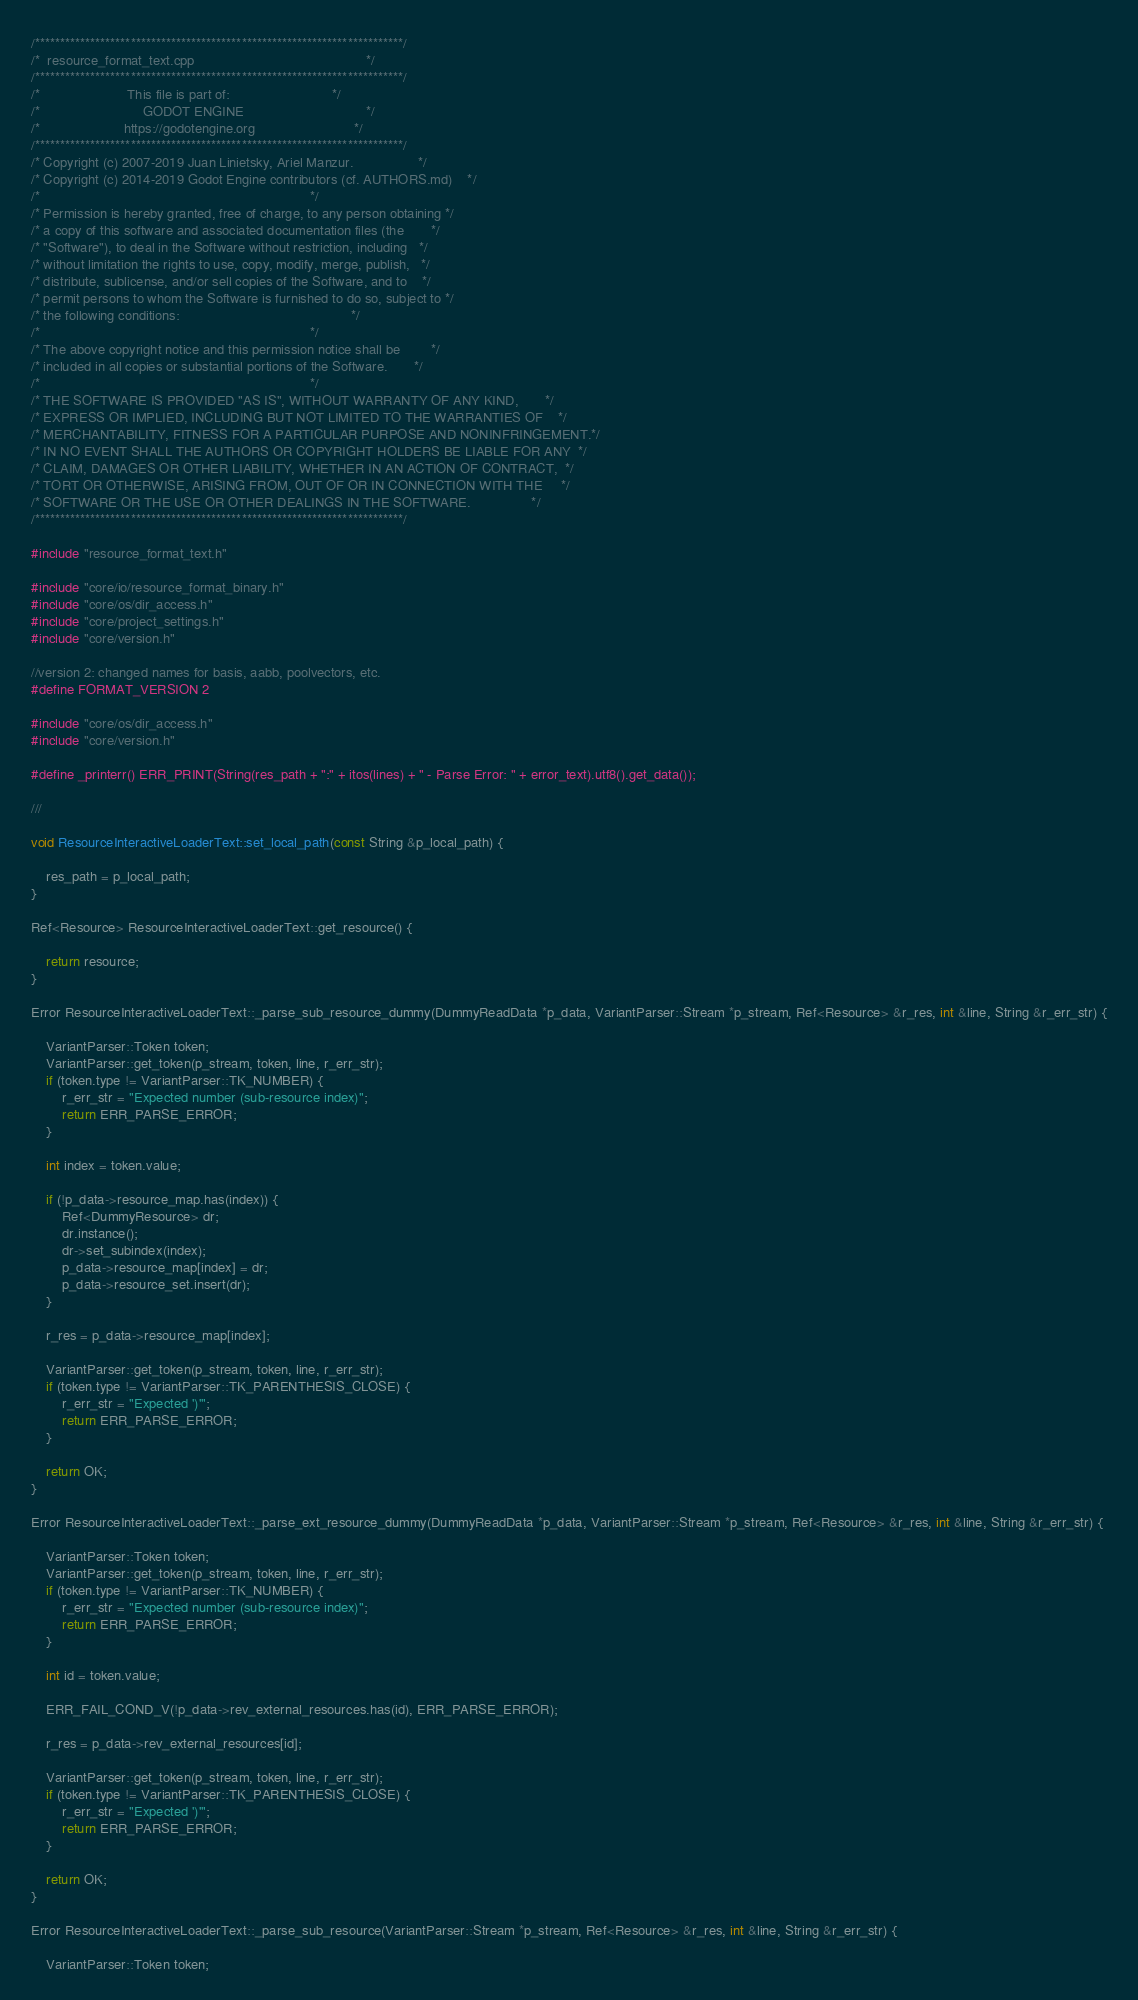Convert code to text. <code><loc_0><loc_0><loc_500><loc_500><_C++_>/*************************************************************************/
/*  resource_format_text.cpp                                             */
/*************************************************************************/
/*                       This file is part of:                           */
/*                           GODOT ENGINE                                */
/*                      https://godotengine.org                          */
/*************************************************************************/
/* Copyright (c) 2007-2019 Juan Linietsky, Ariel Manzur.                 */
/* Copyright (c) 2014-2019 Godot Engine contributors (cf. AUTHORS.md)    */
/*                                                                       */
/* Permission is hereby granted, free of charge, to any person obtaining */
/* a copy of this software and associated documentation files (the       */
/* "Software"), to deal in the Software without restriction, including   */
/* without limitation the rights to use, copy, modify, merge, publish,   */
/* distribute, sublicense, and/or sell copies of the Software, and to    */
/* permit persons to whom the Software is furnished to do so, subject to */
/* the following conditions:                                             */
/*                                                                       */
/* The above copyright notice and this permission notice shall be        */
/* included in all copies or substantial portions of the Software.       */
/*                                                                       */
/* THE SOFTWARE IS PROVIDED "AS IS", WITHOUT WARRANTY OF ANY KIND,       */
/* EXPRESS OR IMPLIED, INCLUDING BUT NOT LIMITED TO THE WARRANTIES OF    */
/* MERCHANTABILITY, FITNESS FOR A PARTICULAR PURPOSE AND NONINFRINGEMENT.*/
/* IN NO EVENT SHALL THE AUTHORS OR COPYRIGHT HOLDERS BE LIABLE FOR ANY  */
/* CLAIM, DAMAGES OR OTHER LIABILITY, WHETHER IN AN ACTION OF CONTRACT,  */
/* TORT OR OTHERWISE, ARISING FROM, OUT OF OR IN CONNECTION WITH THE     */
/* SOFTWARE OR THE USE OR OTHER DEALINGS IN THE SOFTWARE.                */
/*************************************************************************/

#include "resource_format_text.h"

#include "core/io/resource_format_binary.h"
#include "core/os/dir_access.h"
#include "core/project_settings.h"
#include "core/version.h"

//version 2: changed names for basis, aabb, poolvectors, etc.
#define FORMAT_VERSION 2

#include "core/os/dir_access.h"
#include "core/version.h"

#define _printerr() ERR_PRINT(String(res_path + ":" + itos(lines) + " - Parse Error: " + error_text).utf8().get_data());

///

void ResourceInteractiveLoaderText::set_local_path(const String &p_local_path) {

	res_path = p_local_path;
}

Ref<Resource> ResourceInteractiveLoaderText::get_resource() {

	return resource;
}

Error ResourceInteractiveLoaderText::_parse_sub_resource_dummy(DummyReadData *p_data, VariantParser::Stream *p_stream, Ref<Resource> &r_res, int &line, String &r_err_str) {

	VariantParser::Token token;
	VariantParser::get_token(p_stream, token, line, r_err_str);
	if (token.type != VariantParser::TK_NUMBER) {
		r_err_str = "Expected number (sub-resource index)";
		return ERR_PARSE_ERROR;
	}

	int index = token.value;

	if (!p_data->resource_map.has(index)) {
		Ref<DummyResource> dr;
		dr.instance();
		dr->set_subindex(index);
		p_data->resource_map[index] = dr;
		p_data->resource_set.insert(dr);
	}

	r_res = p_data->resource_map[index];

	VariantParser::get_token(p_stream, token, line, r_err_str);
	if (token.type != VariantParser::TK_PARENTHESIS_CLOSE) {
		r_err_str = "Expected ')'";
		return ERR_PARSE_ERROR;
	}

	return OK;
}

Error ResourceInteractiveLoaderText::_parse_ext_resource_dummy(DummyReadData *p_data, VariantParser::Stream *p_stream, Ref<Resource> &r_res, int &line, String &r_err_str) {

	VariantParser::Token token;
	VariantParser::get_token(p_stream, token, line, r_err_str);
	if (token.type != VariantParser::TK_NUMBER) {
		r_err_str = "Expected number (sub-resource index)";
		return ERR_PARSE_ERROR;
	}

	int id = token.value;

	ERR_FAIL_COND_V(!p_data->rev_external_resources.has(id), ERR_PARSE_ERROR);

	r_res = p_data->rev_external_resources[id];

	VariantParser::get_token(p_stream, token, line, r_err_str);
	if (token.type != VariantParser::TK_PARENTHESIS_CLOSE) {
		r_err_str = "Expected ')'";
		return ERR_PARSE_ERROR;
	}

	return OK;
}

Error ResourceInteractiveLoaderText::_parse_sub_resource(VariantParser::Stream *p_stream, Ref<Resource> &r_res, int &line, String &r_err_str) {

	VariantParser::Token token;</code> 